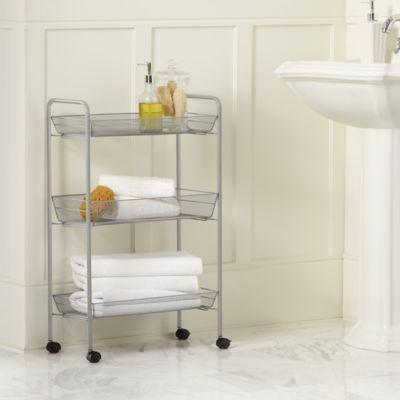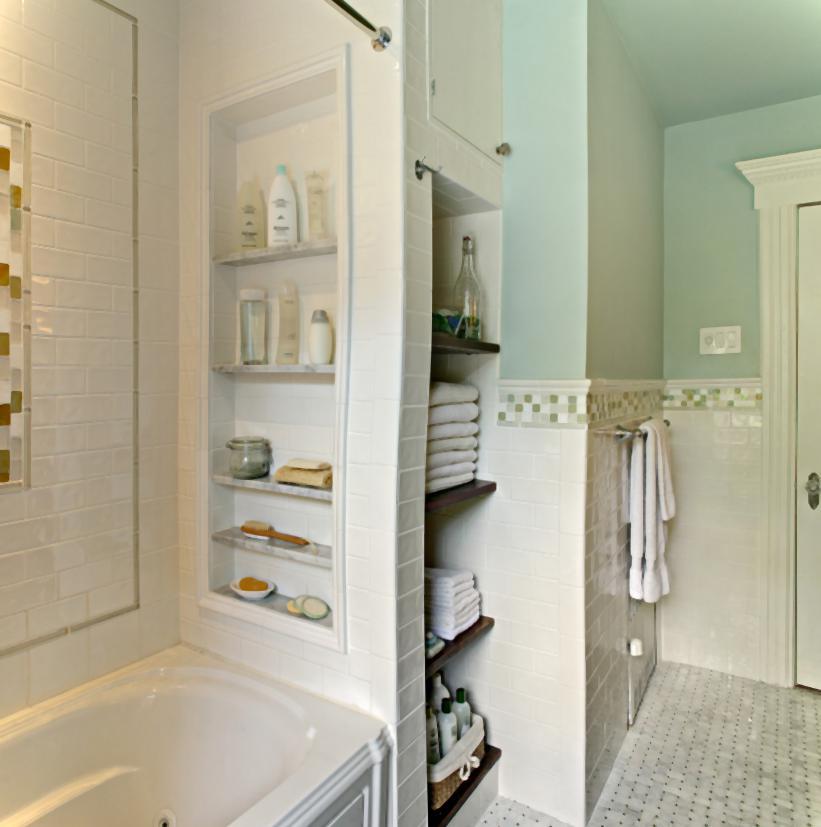The first image is the image on the left, the second image is the image on the right. For the images shown, is this caption "Every towel shown is hanging." true? Answer yes or no. No. 